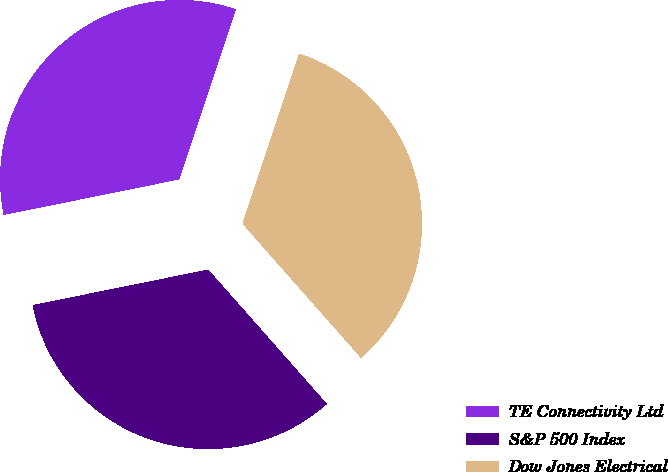<chart> <loc_0><loc_0><loc_500><loc_500><pie_chart><fcel>TE Connectivity Ltd<fcel>S&P 500 Index<fcel>Dow Jones Electrical<nl><fcel>33.3%<fcel>33.33%<fcel>33.37%<nl></chart> 